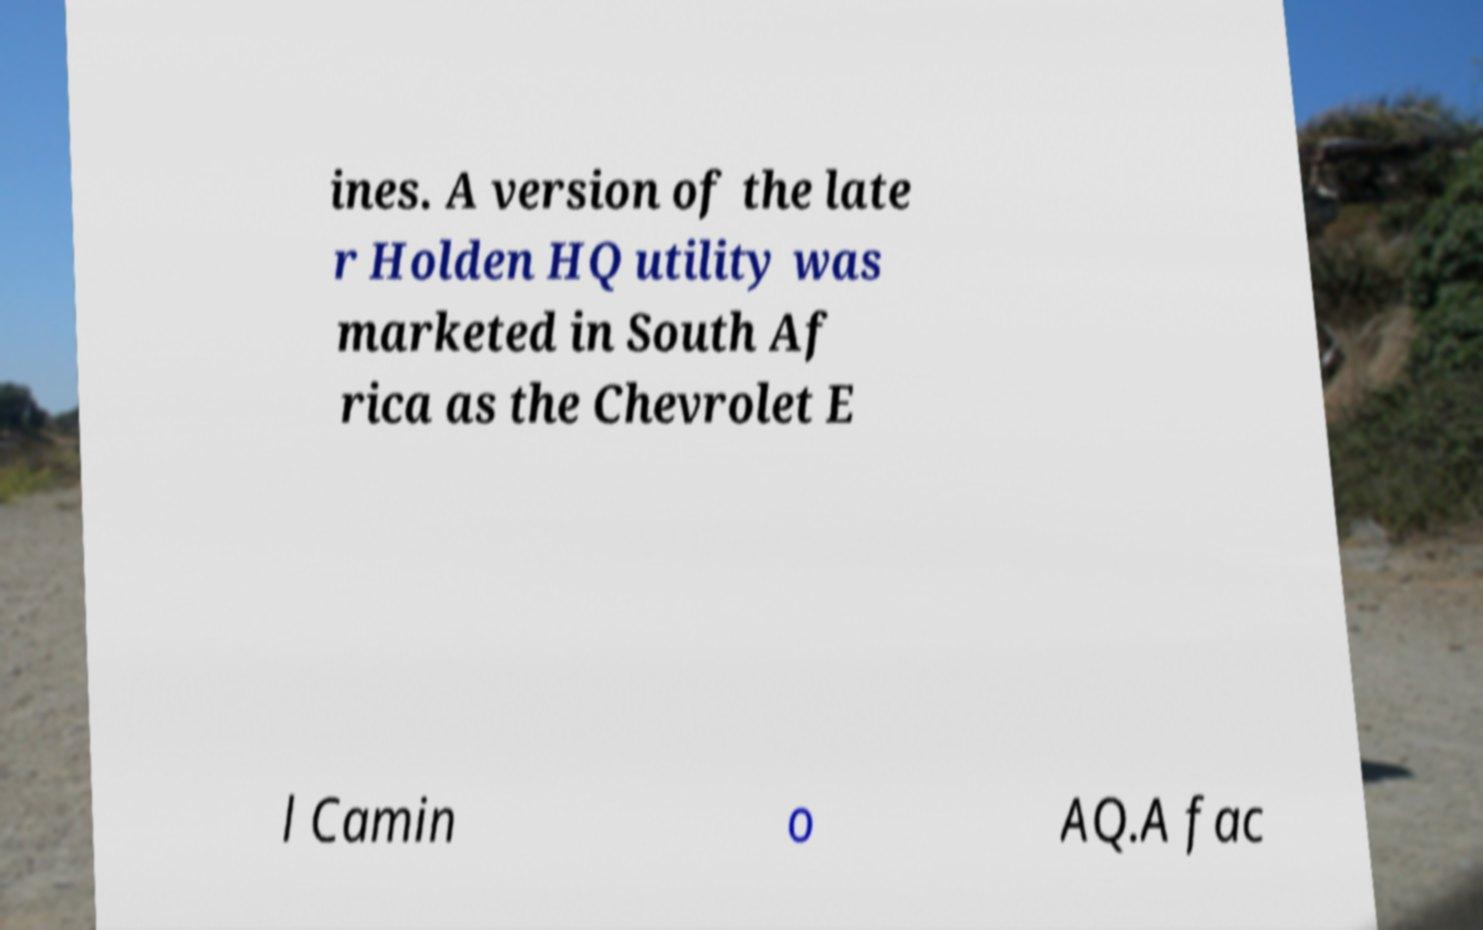Could you extract and type out the text from this image? ines. A version of the late r Holden HQ utility was marketed in South Af rica as the Chevrolet E l Camin o AQ.A fac 